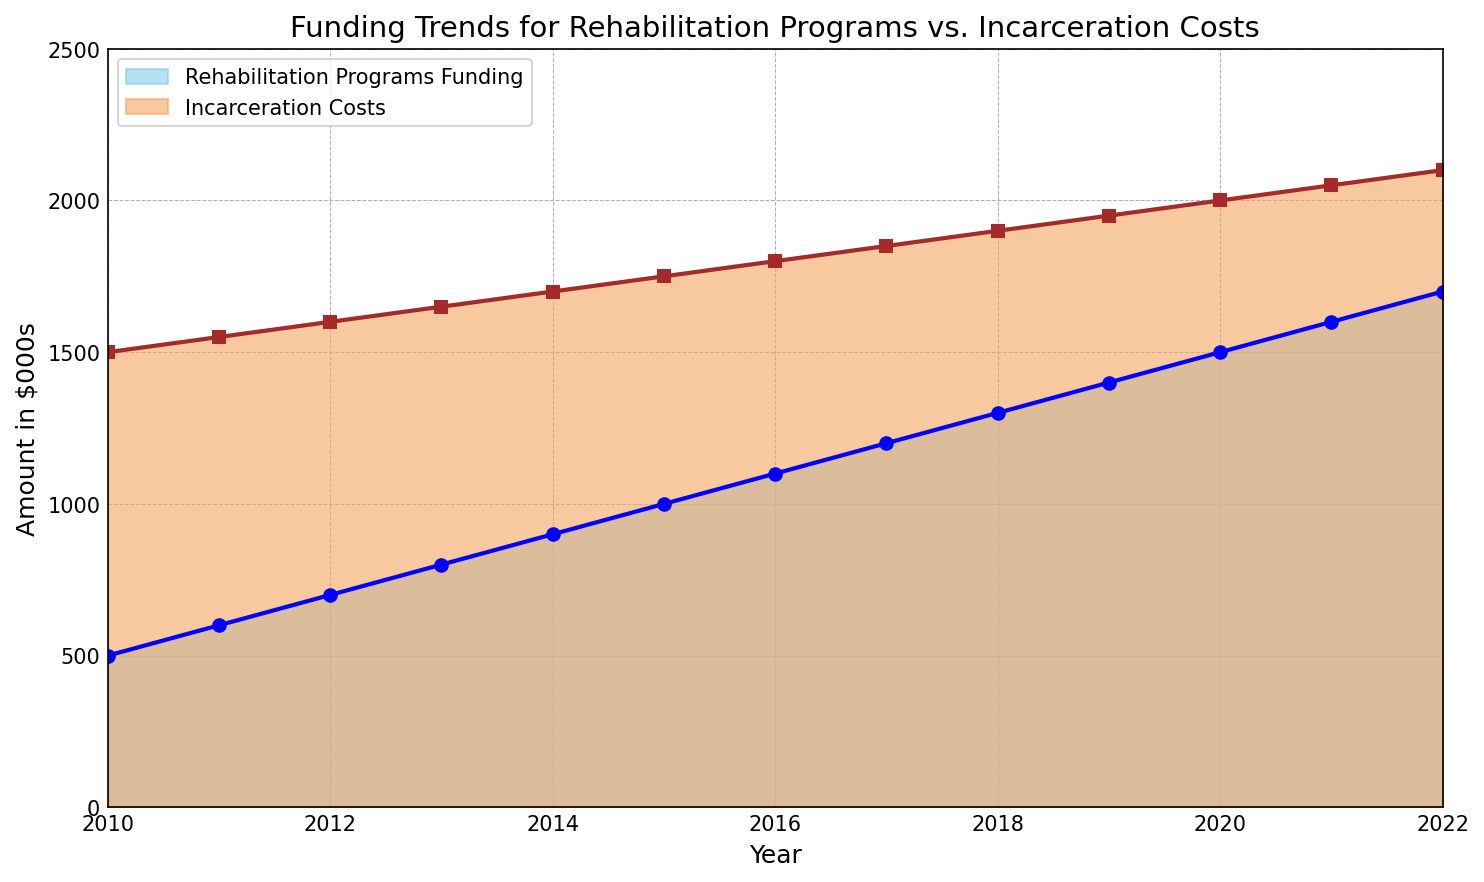Which year had the highest funding for rehabilitation programs? The highest point in the blue filled section indicates the year 2022 with funding reaching $1700.
Answer: 2022 How much did incarceration costs increase from 2010 to 2022? The incarceration costs in 2010 were $1500 and in 2022 they were $2100. The increase is $2100 - $1500 = $600.
Answer: $600 In which year was the difference between incarceration costs and rehabilitation funding the largest? In 2010, incarceration costs were $1500 and rehabilitation funding was $500, giving a difference of $1000, which is the largest.
Answer: 2010 Describe the overall trend in funding for rehabilitation programs from 2010 to 2022. Funding for rehabilitation programs steadily increased each year from $500 in 2010 to $1700 in 2022.
Answer: Steadily increasing How does the funding for rehabilitation programs in 2015 compare to incarceration costs in the same year? In 2015, rehabilitation funding was $1000 while incarceration costs were $1750. Incarceration costs were higher.
Answer: Incarceration costs were higher Which color represents funding for rehabilitation programs in the chart? The blue filled area represents funding for rehabilitation programs.
Answer: Blue Calculate the average funding for rehabilitation programs over the entire period. Sum all the funding values from 2010 to 2022 ($500 + $600 + $700 + $800 + $900 + $1000 + $1100 + $1200 + $1300 + $1400 + $1500 + $1600 + $1700) and divide by the number of years (13). The average is $13900 / 13 ≈ $1070.
Answer: $1070 In which year did both rehabilitation funding and incarceration costs reach $1500? Both rehabilitation funding and incarceration costs reached $1500 in the year 2010 for incarceration costs and 2020 for rehabilitation funding, but they did not reach $1500 in the same year.
Answer: Never 